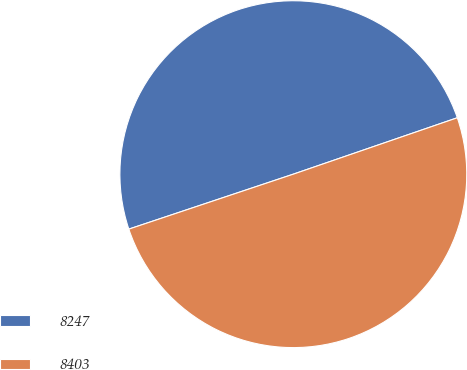<chart> <loc_0><loc_0><loc_500><loc_500><pie_chart><fcel>8247<fcel>8403<nl><fcel>49.86%<fcel>50.14%<nl></chart> 